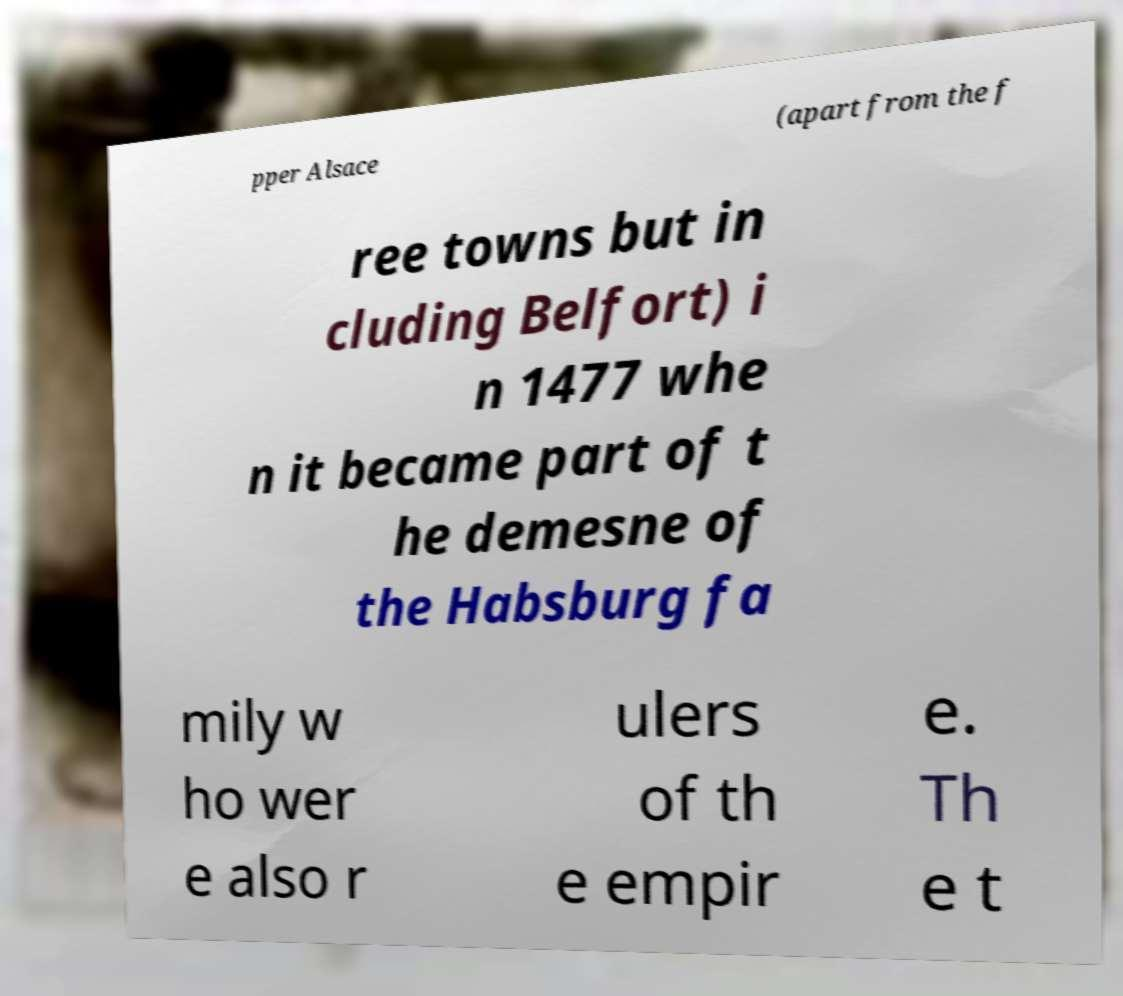Can you read and provide the text displayed in the image?This photo seems to have some interesting text. Can you extract and type it out for me? pper Alsace (apart from the f ree towns but in cluding Belfort) i n 1477 whe n it became part of t he demesne of the Habsburg fa mily w ho wer e also r ulers of th e empir e. Th e t 